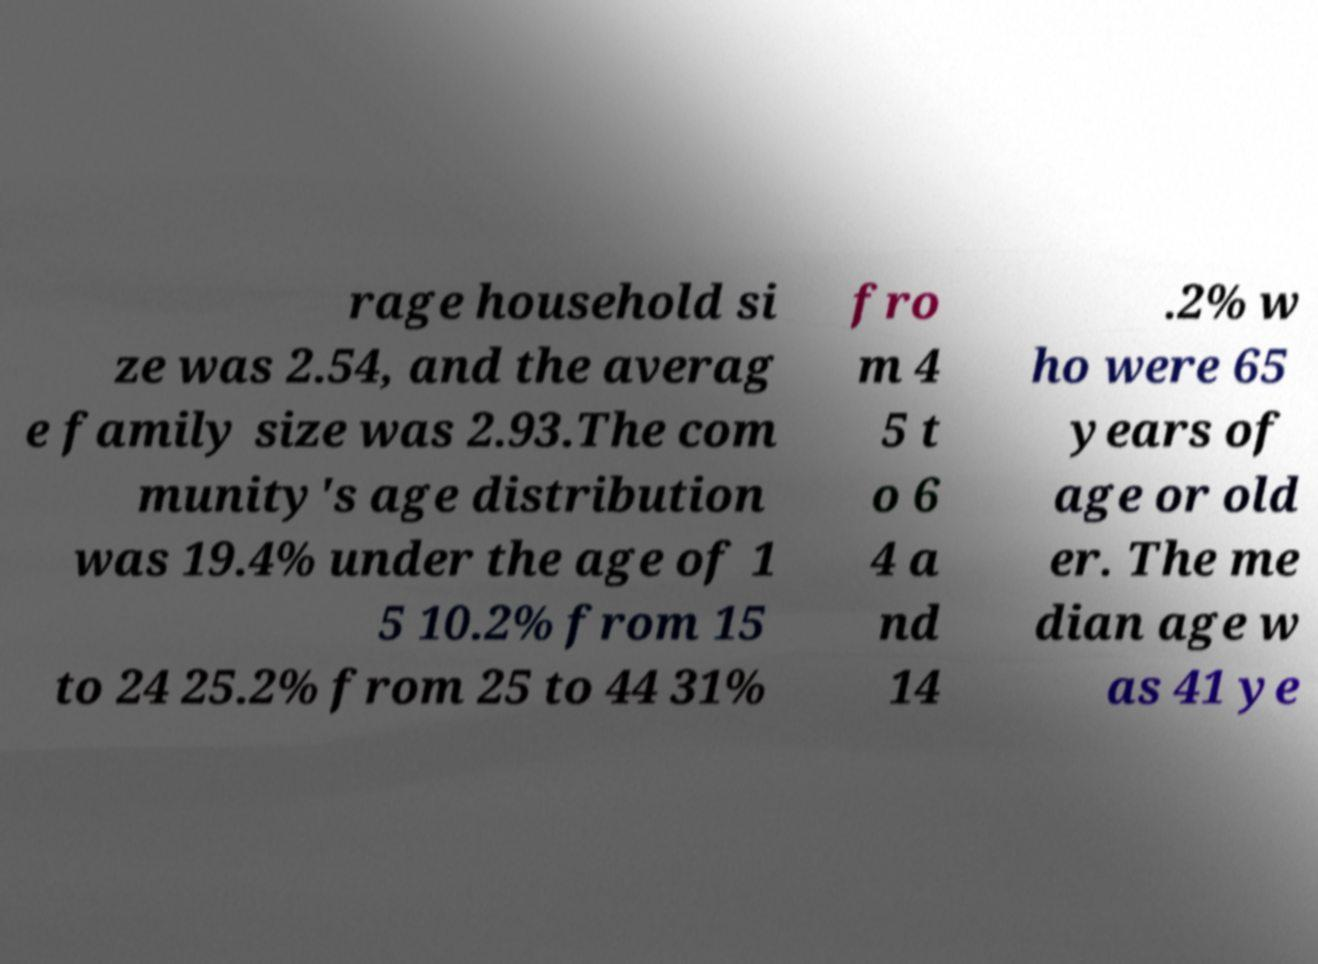Could you extract and type out the text from this image? rage household si ze was 2.54, and the averag e family size was 2.93.The com munity's age distribution was 19.4% under the age of 1 5 10.2% from 15 to 24 25.2% from 25 to 44 31% fro m 4 5 t o 6 4 a nd 14 .2% w ho were 65 years of age or old er. The me dian age w as 41 ye 